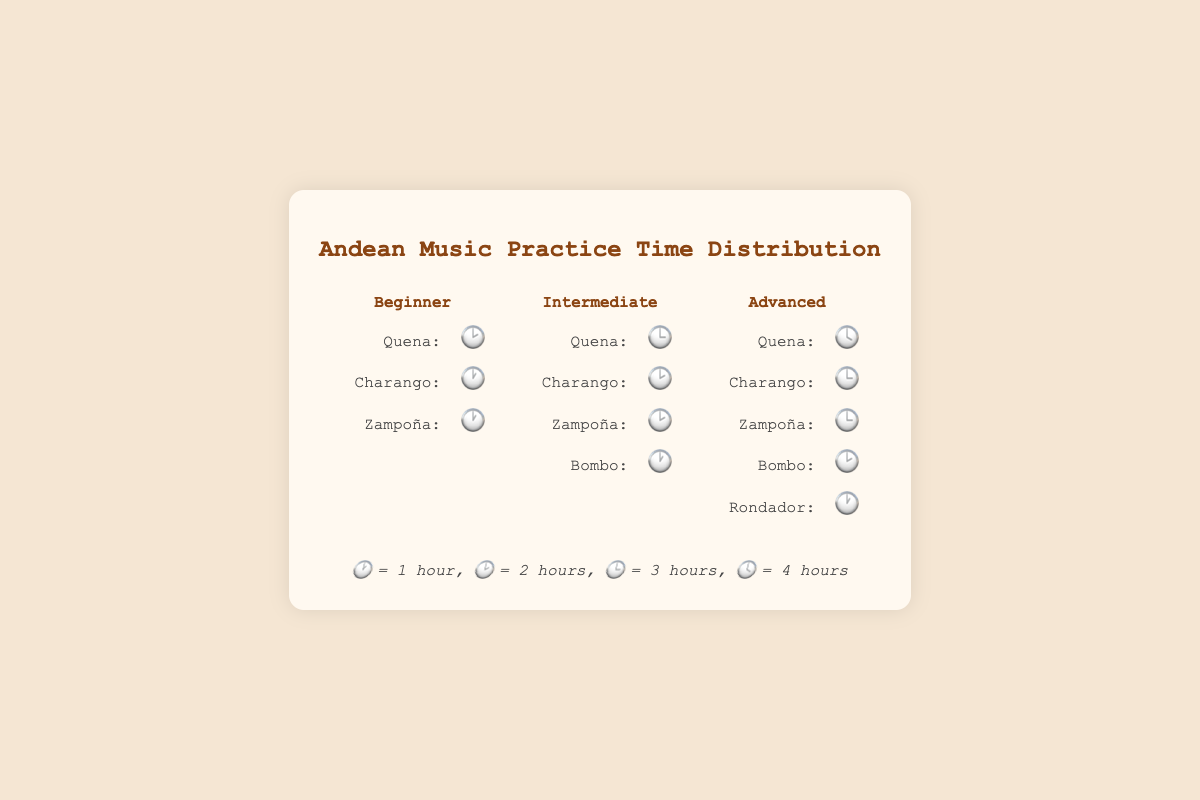What is the total practice time for beginners on Quena? Quena for beginners is marked with "🕑", which represents 2 hours. So, the total practice time is 2 hours.
Answer: 2 hours Which instrument do intermediate players practice for the least amount of time? For intermediate players, "Charango" and "Bombo" are both marked with "🕐", which represents 1 hour. Therefore, they practice these instruments the least.
Answer: Charango and Bombo How much more do advanced players practice Quena compared to intermediate players? Advanced players practice Quena for 4 hours ("🕓") and intermediate players for 3 hours ("🕒"). The difference is 4 - 3 = 1 hour.
Answer: 1 hour How is the practice time distributed among different instruments for advanced players? Advanced players practice: 
- Quena ("🕓") = 4 hours
- Charango ("🕒") = 3 hours
- Zampoña ("🕒") = 3 hours
- Bombo ("🕑") = 2 hours
- Rondador ("🕐") = 1 hour
Answer: Quena: 4 hours, Charango: 3 hours, Zampoña: 3 hours, Bombo: 2 hours, Rondador: 1 hour What is the total practice time for an advanced player across all instruments? For advanced players:
Quena = 4 hours, Charango = 3 hours, Zampoña = 3 hours, Bombo = 2 hours, Rondador = 1 hour. Total = 4 + 3 + 3 + 2 + 1 = 13 hours.
Answer: 13 hours Do any skill levels practice more than 3 instruments? To determine this, we observe the number of instruments each skill level practices:
- Beginner: 3 instruments (Quena, Charango, Zampoña)
- Intermediate: 4 instruments (Quena, Charango, Zampoña, Bombo)
- Advanced: 5 instruments (Quena, Charango, Zampoña, Bombo, Rondador)
Both intermediate and advanced levels practice more than 3 instruments.
Answer: Intermediate and Advanced Which skill level practices Charango for the longest amount of time? Advanced players practice Charango for 3 hours ("🕒"), which is more than intermediate (2 hours, "🕑") and beginner (1 hour, "🕐").
Answer: Advanced What’s the average practice time for Zampoña across all skill levels? Zampoña practice times are:
- Beginner: 1 hour ("🕐")
- Intermediate: 2 hours ("🕑")
- Advanced: 3 hours ("🕒")
Average = (1 + 2 + 3) / 3 = 2 hours.
Answer: 2 hours How does the practice time for Bombo compare between intermediate and advanced players? Intermediate players practice Bombo for 1 hour ("🕐") and advanced players for 2 hours ("🕑"). Advanced players practice 1 hour more than intermediate players.
Answer: Advanced players practice 1 hour more What is the most practiced instrument for advanced players? Advanced players practice Quena the most, for 4 hours ("🕓").
Answer: Quena 